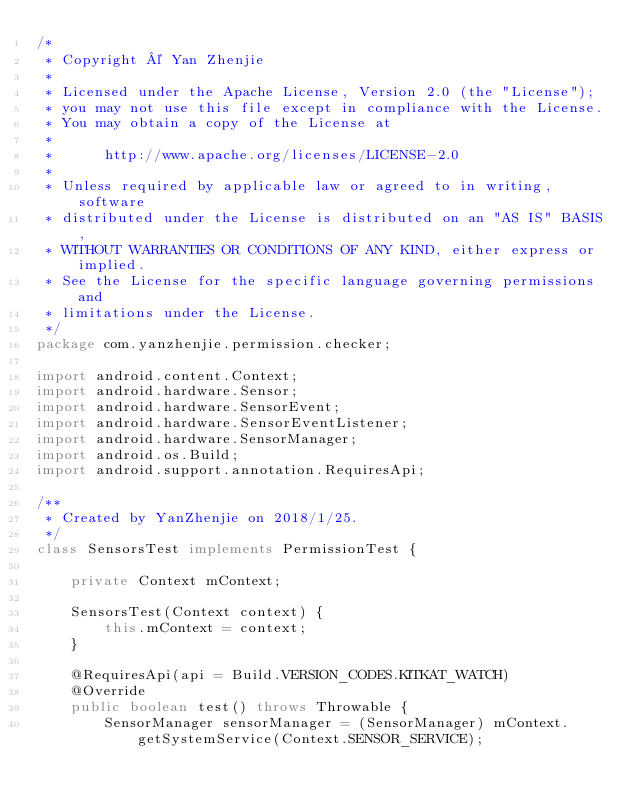<code> <loc_0><loc_0><loc_500><loc_500><_Java_>/*
 * Copyright © Yan Zhenjie
 *
 * Licensed under the Apache License, Version 2.0 (the "License");
 * you may not use this file except in compliance with the License.
 * You may obtain a copy of the License at
 *
 *      http://www.apache.org/licenses/LICENSE-2.0
 *
 * Unless required by applicable law or agreed to in writing, software
 * distributed under the License is distributed on an "AS IS" BASIS,
 * WITHOUT WARRANTIES OR CONDITIONS OF ANY KIND, either express or implied.
 * See the License for the specific language governing permissions and
 * limitations under the License.
 */
package com.yanzhenjie.permission.checker;

import android.content.Context;
import android.hardware.Sensor;
import android.hardware.SensorEvent;
import android.hardware.SensorEventListener;
import android.hardware.SensorManager;
import android.os.Build;
import android.support.annotation.RequiresApi;

/**
 * Created by YanZhenjie on 2018/1/25.
 */
class SensorsTest implements PermissionTest {

    private Context mContext;

    SensorsTest(Context context) {
        this.mContext = context;
    }

    @RequiresApi(api = Build.VERSION_CODES.KITKAT_WATCH)
    @Override
    public boolean test() throws Throwable {
        SensorManager sensorManager = (SensorManager) mContext.getSystemService(Context.SENSOR_SERVICE);</code> 